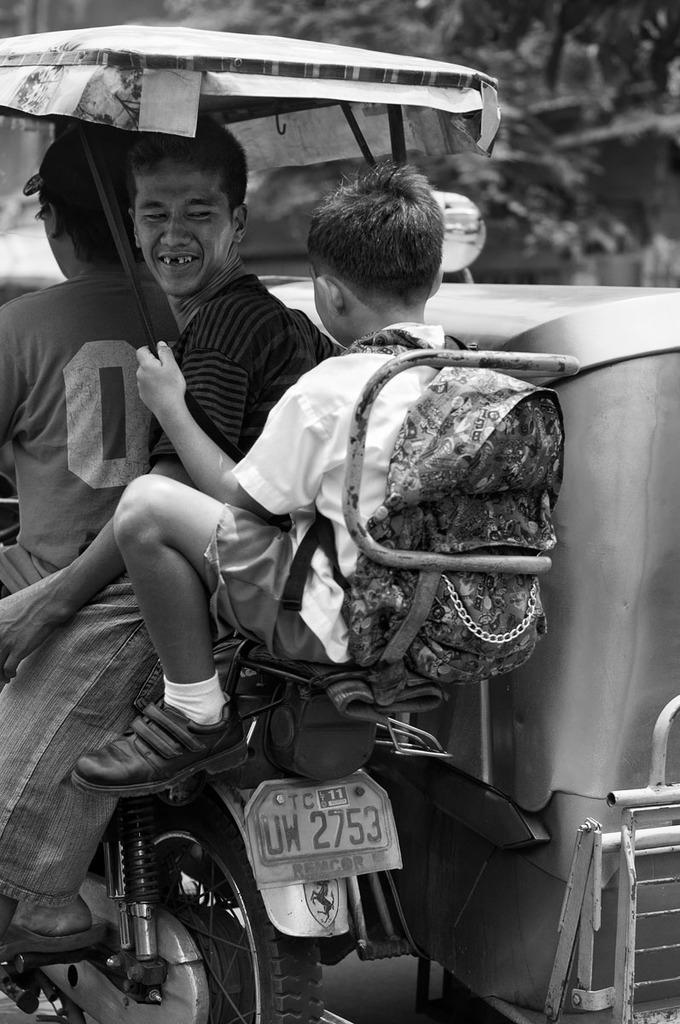How would you summarize this image in a sentence or two? These three persons are sitting on the vehicle and this person riding,this person holding umbrella and wear bag. On the background we can see trees. 